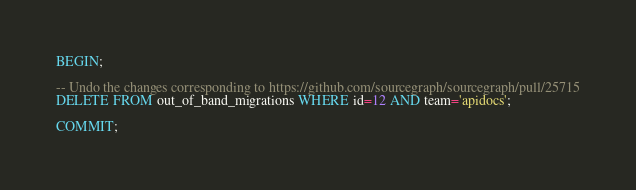Convert code to text. <code><loc_0><loc_0><loc_500><loc_500><_SQL_>BEGIN;

-- Undo the changes corresponding to https://github.com/sourcegraph/sourcegraph/pull/25715
DELETE FROM out_of_band_migrations WHERE id=12 AND team='apidocs';

COMMIT;
</code> 